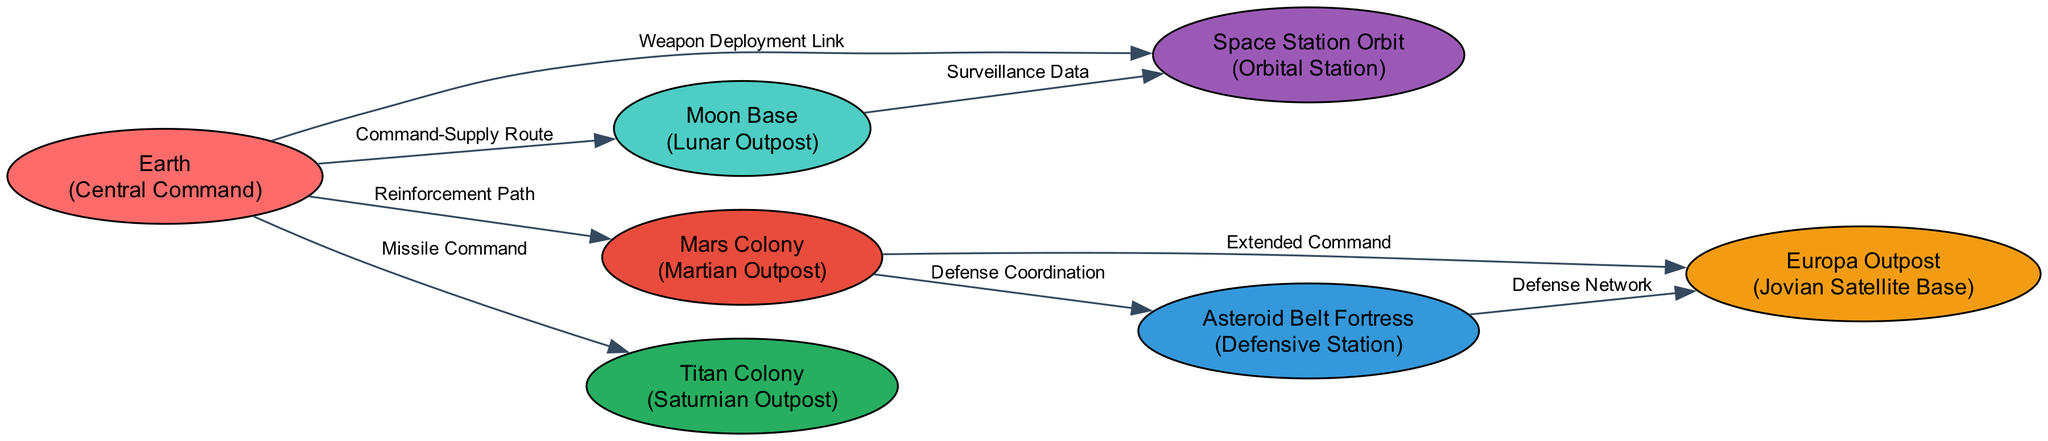What type is the Earth node? The Earth node is classified as a "Central Command," which is indicated in the node's description in the diagram.
Answer: Central Command How many edges connect to the Mars Colony? By inspecting the diagram, the Mars Colony is connected to three edges: one from Earth, one to the Asteroid Belt Fortress, and one to the Europa Outpost.
Answer: 3 What is the label of the connection between Moon Base and Space Station Orbit? The connection from the Moon Base to the Space Station Orbit is labeled "Surveillance Data," as shown in the diagram.
Answer: Surveillance Data Which node has the weapon deployment link? The Earth node has the "Weapon Deployment Link" connection, as specified in the edge description leading to the Space Station Orbit.
Answer: Earth What type of outpost is the Titan Colony? The Titan Colony is categorized as a "Saturnian Outpost" based on the node's description within the diagram.
Answer: Saturnian Outpost What is the relationship between Mars Colony and Asteroid Belt Fortress? The relationship is described as "Defense Coordination," indicating a collaborative effort in defensive operations as per the edge linking them.
Answer: Defense Coordination Which node serves as the hub for all weapon systems control? The hub for all weapon systems control is the Earth node, as denoted in its description.
Answer: Earth What type of communication exists from the Earth to the Moon Base? The communication is labeled as "Command-Supply Route," which describes the primary logistical channel between the Earth and the Moon Base.
Answer: Command-Supply Route How many defensive stations are mentioned in the diagram? There is one defensive station mentioned, which is the Asteroid Belt Fortress, based on the nodes listed in the diagram.
Answer: 1 